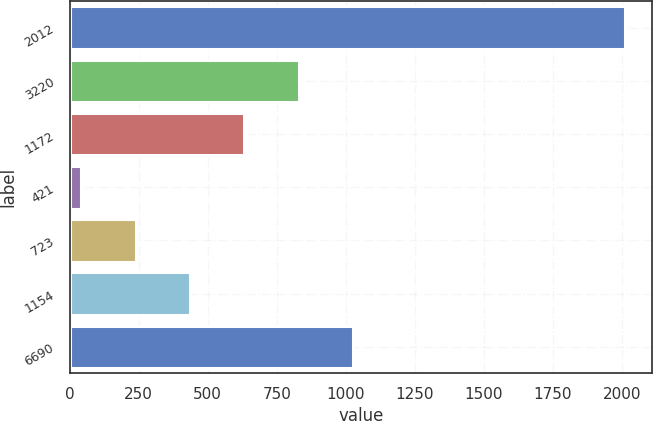<chart> <loc_0><loc_0><loc_500><loc_500><bar_chart><fcel>2012<fcel>3220<fcel>1172<fcel>421<fcel>723<fcel>1154<fcel>6690<nl><fcel>2010<fcel>829.44<fcel>632.68<fcel>42.4<fcel>239.16<fcel>435.92<fcel>1026.2<nl></chart> 